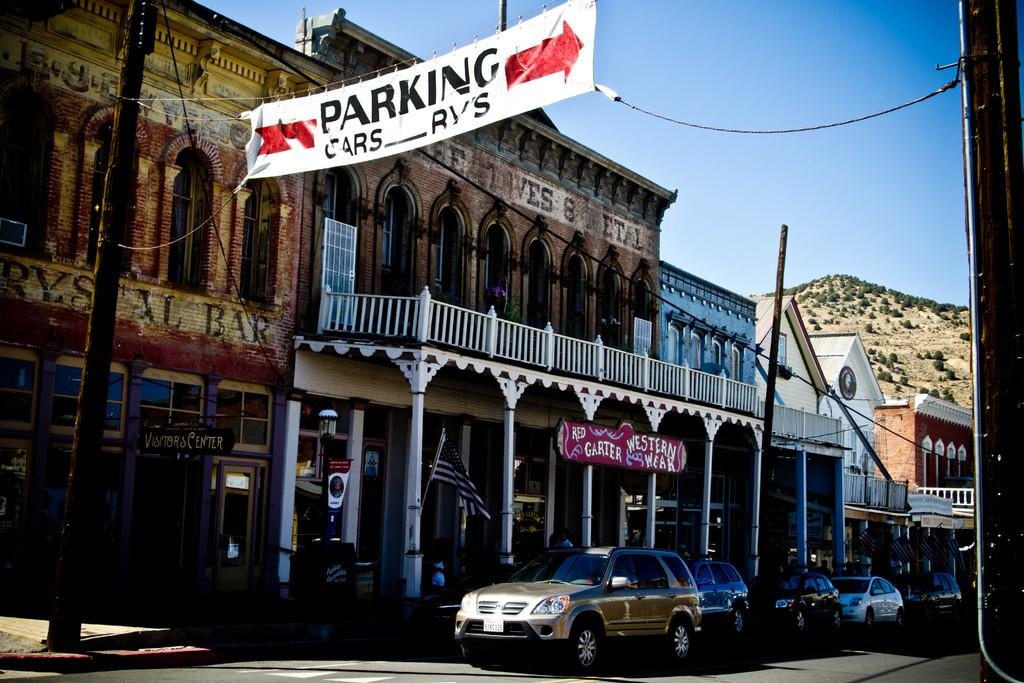<image>
Render a clear and concise summary of the photo. a building with a parking sign above everything 